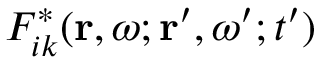Convert formula to latex. <formula><loc_0><loc_0><loc_500><loc_500>F _ { i k } ^ { * } ( r , \omega ; r ^ { \prime } , \omega ^ { \prime } ; t ^ { \prime } )</formula> 